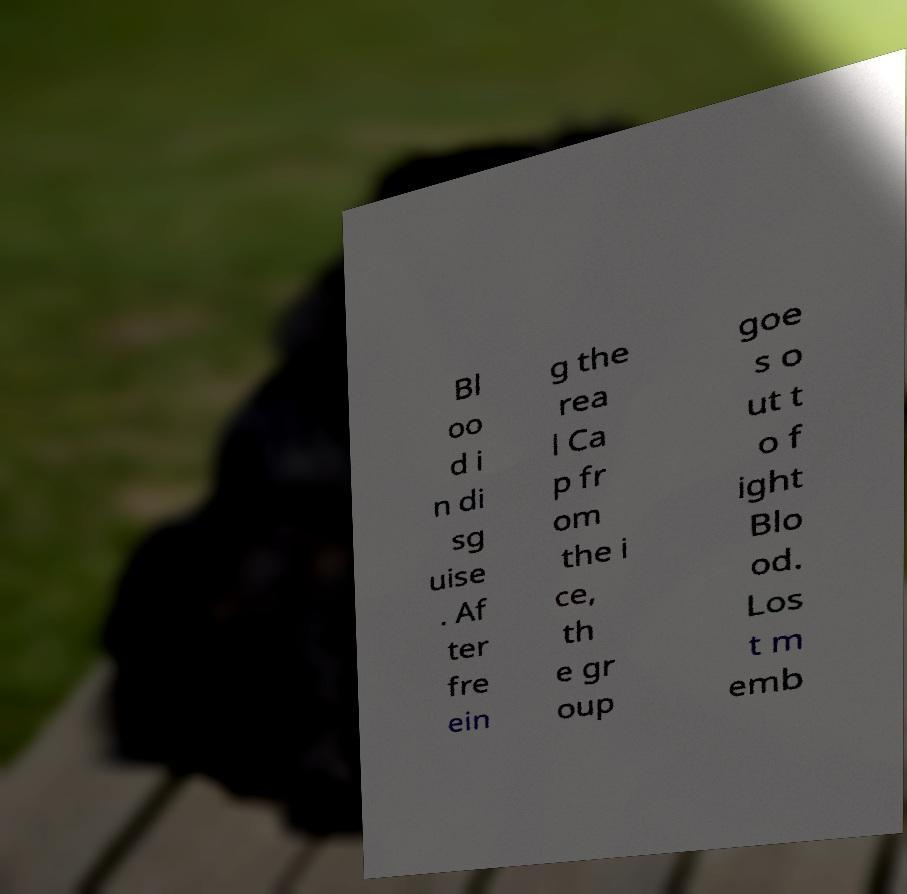What messages or text are displayed in this image? I need them in a readable, typed format. Bl oo d i n di sg uise . Af ter fre ein g the rea l Ca p fr om the i ce, th e gr oup goe s o ut t o f ight Blo od. Los t m emb 